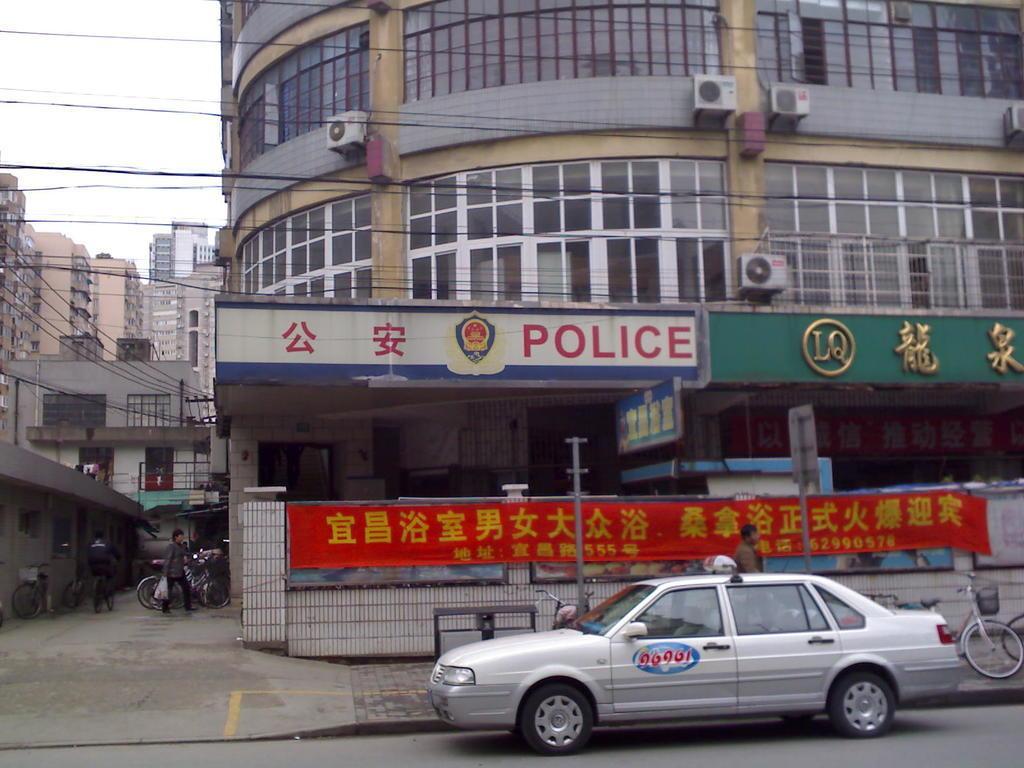Could you give a brief overview of what you see in this image? In this picture, there is a road on the road which is at the bottom. Behind it, there are bicycles and a man. On the top right, there is a building with windows, text and air conditioners etc. Towards the bottom left, there are people and bicycles. Towards the left, there are buildings and sky. 